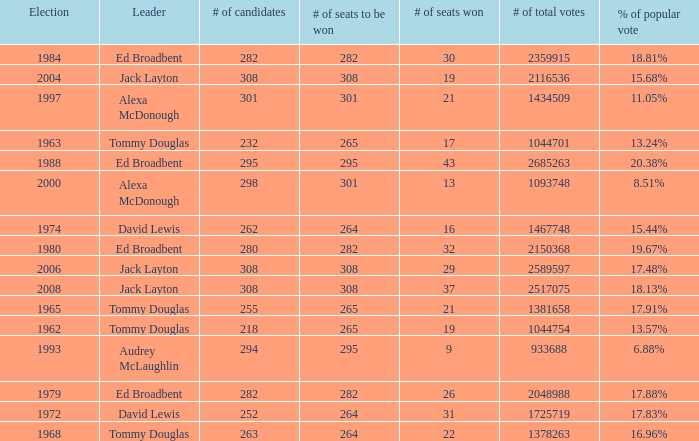Name the number of seats to be won being % of popular vote at 6.88% 295.0. 